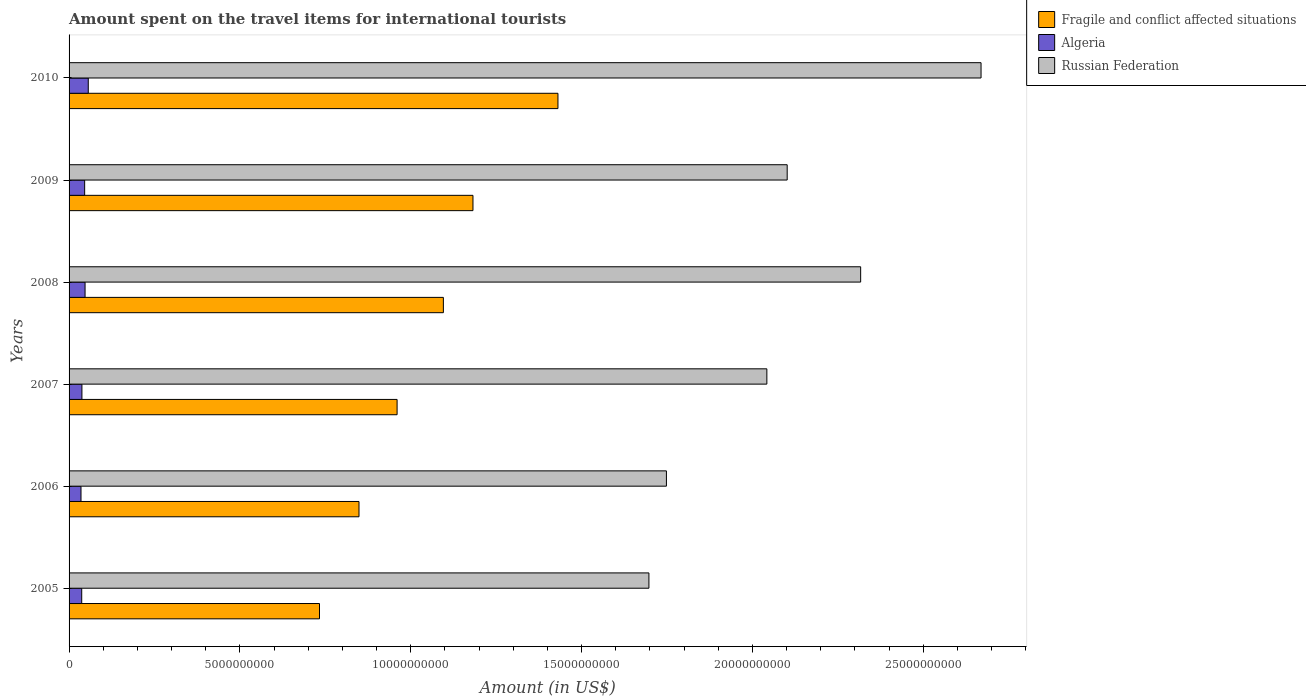Are the number of bars per tick equal to the number of legend labels?
Ensure brevity in your answer.  Yes. What is the amount spent on the travel items for international tourists in Fragile and conflict affected situations in 2009?
Your answer should be very brief. 1.18e+1. Across all years, what is the maximum amount spent on the travel items for international tourists in Algeria?
Give a very brief answer. 5.62e+08. Across all years, what is the minimum amount spent on the travel items for international tourists in Russian Federation?
Your answer should be very brief. 1.70e+1. In which year was the amount spent on the travel items for international tourists in Fragile and conflict affected situations minimum?
Offer a terse response. 2005. What is the total amount spent on the travel items for international tourists in Fragile and conflict affected situations in the graph?
Keep it short and to the point. 6.25e+1. What is the difference between the amount spent on the travel items for international tourists in Russian Federation in 2006 and that in 2008?
Provide a succinct answer. -5.68e+09. What is the difference between the amount spent on the travel items for international tourists in Russian Federation in 2010 and the amount spent on the travel items for international tourists in Algeria in 2008?
Give a very brief answer. 2.62e+1. What is the average amount spent on the travel items for international tourists in Russian Federation per year?
Your answer should be very brief. 2.10e+1. In the year 2009, what is the difference between the amount spent on the travel items for international tourists in Russian Federation and amount spent on the travel items for international tourists in Algeria?
Provide a succinct answer. 2.06e+1. What is the ratio of the amount spent on the travel items for international tourists in Russian Federation in 2009 to that in 2010?
Your answer should be very brief. 0.79. Is the difference between the amount spent on the travel items for international tourists in Russian Federation in 2006 and 2010 greater than the difference between the amount spent on the travel items for international tourists in Algeria in 2006 and 2010?
Give a very brief answer. No. What is the difference between the highest and the second highest amount spent on the travel items for international tourists in Fragile and conflict affected situations?
Offer a very short reply. 2.49e+09. What is the difference between the highest and the lowest amount spent on the travel items for international tourists in Algeria?
Provide a succinct answer. 2.13e+08. Is the sum of the amount spent on the travel items for international tourists in Russian Federation in 2007 and 2008 greater than the maximum amount spent on the travel items for international tourists in Fragile and conflict affected situations across all years?
Your answer should be compact. Yes. What does the 1st bar from the top in 2008 represents?
Offer a very short reply. Russian Federation. What does the 2nd bar from the bottom in 2006 represents?
Your answer should be compact. Algeria. How many bars are there?
Your answer should be compact. 18. How many years are there in the graph?
Keep it short and to the point. 6. Are the values on the major ticks of X-axis written in scientific E-notation?
Offer a very short reply. No. Does the graph contain grids?
Provide a short and direct response. No. Where does the legend appear in the graph?
Provide a succinct answer. Top right. How many legend labels are there?
Make the answer very short. 3. What is the title of the graph?
Make the answer very short. Amount spent on the travel items for international tourists. What is the label or title of the X-axis?
Make the answer very short. Amount (in US$). What is the Amount (in US$) in Fragile and conflict affected situations in 2005?
Your answer should be very brief. 7.33e+09. What is the Amount (in US$) in Algeria in 2005?
Provide a succinct answer. 3.70e+08. What is the Amount (in US$) of Russian Federation in 2005?
Provide a succinct answer. 1.70e+1. What is the Amount (in US$) in Fragile and conflict affected situations in 2006?
Offer a terse response. 8.49e+09. What is the Amount (in US$) of Algeria in 2006?
Provide a short and direct response. 3.49e+08. What is the Amount (in US$) in Russian Federation in 2006?
Offer a terse response. 1.75e+1. What is the Amount (in US$) in Fragile and conflict affected situations in 2007?
Provide a short and direct response. 9.60e+09. What is the Amount (in US$) in Algeria in 2007?
Provide a succinct answer. 3.76e+08. What is the Amount (in US$) in Russian Federation in 2007?
Give a very brief answer. 2.04e+1. What is the Amount (in US$) in Fragile and conflict affected situations in 2008?
Ensure brevity in your answer.  1.10e+1. What is the Amount (in US$) in Algeria in 2008?
Give a very brief answer. 4.68e+08. What is the Amount (in US$) of Russian Federation in 2008?
Provide a succinct answer. 2.32e+1. What is the Amount (in US$) of Fragile and conflict affected situations in 2009?
Provide a succinct answer. 1.18e+1. What is the Amount (in US$) of Algeria in 2009?
Your response must be concise. 4.56e+08. What is the Amount (in US$) of Russian Federation in 2009?
Your answer should be compact. 2.10e+1. What is the Amount (in US$) in Fragile and conflict affected situations in 2010?
Offer a very short reply. 1.43e+1. What is the Amount (in US$) in Algeria in 2010?
Your answer should be compact. 5.62e+08. What is the Amount (in US$) of Russian Federation in 2010?
Provide a short and direct response. 2.67e+1. Across all years, what is the maximum Amount (in US$) of Fragile and conflict affected situations?
Your answer should be very brief. 1.43e+1. Across all years, what is the maximum Amount (in US$) in Algeria?
Provide a short and direct response. 5.62e+08. Across all years, what is the maximum Amount (in US$) of Russian Federation?
Make the answer very short. 2.67e+1. Across all years, what is the minimum Amount (in US$) of Fragile and conflict affected situations?
Ensure brevity in your answer.  7.33e+09. Across all years, what is the minimum Amount (in US$) in Algeria?
Offer a very short reply. 3.49e+08. Across all years, what is the minimum Amount (in US$) in Russian Federation?
Offer a terse response. 1.70e+1. What is the total Amount (in US$) of Fragile and conflict affected situations in the graph?
Offer a very short reply. 6.25e+1. What is the total Amount (in US$) of Algeria in the graph?
Your answer should be very brief. 2.58e+09. What is the total Amount (in US$) in Russian Federation in the graph?
Provide a short and direct response. 1.26e+11. What is the difference between the Amount (in US$) in Fragile and conflict affected situations in 2005 and that in 2006?
Your response must be concise. -1.16e+09. What is the difference between the Amount (in US$) of Algeria in 2005 and that in 2006?
Provide a succinct answer. 2.10e+07. What is the difference between the Amount (in US$) of Russian Federation in 2005 and that in 2006?
Keep it short and to the point. -5.12e+08. What is the difference between the Amount (in US$) in Fragile and conflict affected situations in 2005 and that in 2007?
Your response must be concise. -2.27e+09. What is the difference between the Amount (in US$) of Algeria in 2005 and that in 2007?
Your answer should be very brief. -6.00e+06. What is the difference between the Amount (in US$) in Russian Federation in 2005 and that in 2007?
Make the answer very short. -3.45e+09. What is the difference between the Amount (in US$) in Fragile and conflict affected situations in 2005 and that in 2008?
Your answer should be compact. -3.63e+09. What is the difference between the Amount (in US$) of Algeria in 2005 and that in 2008?
Keep it short and to the point. -9.80e+07. What is the difference between the Amount (in US$) in Russian Federation in 2005 and that in 2008?
Provide a short and direct response. -6.20e+09. What is the difference between the Amount (in US$) of Fragile and conflict affected situations in 2005 and that in 2009?
Offer a very short reply. -4.49e+09. What is the difference between the Amount (in US$) of Algeria in 2005 and that in 2009?
Your response must be concise. -8.60e+07. What is the difference between the Amount (in US$) in Russian Federation in 2005 and that in 2009?
Provide a succinct answer. -4.05e+09. What is the difference between the Amount (in US$) of Fragile and conflict affected situations in 2005 and that in 2010?
Provide a short and direct response. -6.98e+09. What is the difference between the Amount (in US$) of Algeria in 2005 and that in 2010?
Offer a very short reply. -1.92e+08. What is the difference between the Amount (in US$) of Russian Federation in 2005 and that in 2010?
Ensure brevity in your answer.  -9.72e+09. What is the difference between the Amount (in US$) of Fragile and conflict affected situations in 2006 and that in 2007?
Give a very brief answer. -1.11e+09. What is the difference between the Amount (in US$) in Algeria in 2006 and that in 2007?
Your response must be concise. -2.70e+07. What is the difference between the Amount (in US$) of Russian Federation in 2006 and that in 2007?
Provide a succinct answer. -2.94e+09. What is the difference between the Amount (in US$) in Fragile and conflict affected situations in 2006 and that in 2008?
Give a very brief answer. -2.47e+09. What is the difference between the Amount (in US$) in Algeria in 2006 and that in 2008?
Keep it short and to the point. -1.19e+08. What is the difference between the Amount (in US$) in Russian Federation in 2006 and that in 2008?
Provide a short and direct response. -5.68e+09. What is the difference between the Amount (in US$) of Fragile and conflict affected situations in 2006 and that in 2009?
Your response must be concise. -3.34e+09. What is the difference between the Amount (in US$) of Algeria in 2006 and that in 2009?
Keep it short and to the point. -1.07e+08. What is the difference between the Amount (in US$) of Russian Federation in 2006 and that in 2009?
Your response must be concise. -3.54e+09. What is the difference between the Amount (in US$) of Fragile and conflict affected situations in 2006 and that in 2010?
Make the answer very short. -5.82e+09. What is the difference between the Amount (in US$) in Algeria in 2006 and that in 2010?
Give a very brief answer. -2.13e+08. What is the difference between the Amount (in US$) in Russian Federation in 2006 and that in 2010?
Ensure brevity in your answer.  -9.21e+09. What is the difference between the Amount (in US$) in Fragile and conflict affected situations in 2007 and that in 2008?
Give a very brief answer. -1.35e+09. What is the difference between the Amount (in US$) in Algeria in 2007 and that in 2008?
Provide a short and direct response. -9.20e+07. What is the difference between the Amount (in US$) of Russian Federation in 2007 and that in 2008?
Provide a short and direct response. -2.74e+09. What is the difference between the Amount (in US$) of Fragile and conflict affected situations in 2007 and that in 2009?
Ensure brevity in your answer.  -2.22e+09. What is the difference between the Amount (in US$) of Algeria in 2007 and that in 2009?
Offer a terse response. -8.00e+07. What is the difference between the Amount (in US$) of Russian Federation in 2007 and that in 2009?
Give a very brief answer. -5.95e+08. What is the difference between the Amount (in US$) in Fragile and conflict affected situations in 2007 and that in 2010?
Offer a very short reply. -4.71e+09. What is the difference between the Amount (in US$) of Algeria in 2007 and that in 2010?
Keep it short and to the point. -1.86e+08. What is the difference between the Amount (in US$) of Russian Federation in 2007 and that in 2010?
Make the answer very short. -6.27e+09. What is the difference between the Amount (in US$) of Fragile and conflict affected situations in 2008 and that in 2009?
Your answer should be compact. -8.66e+08. What is the difference between the Amount (in US$) of Russian Federation in 2008 and that in 2009?
Your answer should be compact. 2.15e+09. What is the difference between the Amount (in US$) in Fragile and conflict affected situations in 2008 and that in 2010?
Make the answer very short. -3.35e+09. What is the difference between the Amount (in US$) in Algeria in 2008 and that in 2010?
Ensure brevity in your answer.  -9.40e+07. What is the difference between the Amount (in US$) in Russian Federation in 2008 and that in 2010?
Provide a short and direct response. -3.52e+09. What is the difference between the Amount (in US$) in Fragile and conflict affected situations in 2009 and that in 2010?
Your response must be concise. -2.49e+09. What is the difference between the Amount (in US$) of Algeria in 2009 and that in 2010?
Your response must be concise. -1.06e+08. What is the difference between the Amount (in US$) of Russian Federation in 2009 and that in 2010?
Make the answer very short. -5.67e+09. What is the difference between the Amount (in US$) of Fragile and conflict affected situations in 2005 and the Amount (in US$) of Algeria in 2006?
Your answer should be very brief. 6.98e+09. What is the difference between the Amount (in US$) in Fragile and conflict affected situations in 2005 and the Amount (in US$) in Russian Federation in 2006?
Your answer should be compact. -1.02e+1. What is the difference between the Amount (in US$) in Algeria in 2005 and the Amount (in US$) in Russian Federation in 2006?
Offer a terse response. -1.71e+1. What is the difference between the Amount (in US$) of Fragile and conflict affected situations in 2005 and the Amount (in US$) of Algeria in 2007?
Your response must be concise. 6.95e+09. What is the difference between the Amount (in US$) in Fragile and conflict affected situations in 2005 and the Amount (in US$) in Russian Federation in 2007?
Your answer should be compact. -1.31e+1. What is the difference between the Amount (in US$) of Algeria in 2005 and the Amount (in US$) of Russian Federation in 2007?
Keep it short and to the point. -2.01e+1. What is the difference between the Amount (in US$) of Fragile and conflict affected situations in 2005 and the Amount (in US$) of Algeria in 2008?
Your response must be concise. 6.86e+09. What is the difference between the Amount (in US$) of Fragile and conflict affected situations in 2005 and the Amount (in US$) of Russian Federation in 2008?
Your answer should be very brief. -1.58e+1. What is the difference between the Amount (in US$) of Algeria in 2005 and the Amount (in US$) of Russian Federation in 2008?
Provide a short and direct response. -2.28e+1. What is the difference between the Amount (in US$) of Fragile and conflict affected situations in 2005 and the Amount (in US$) of Algeria in 2009?
Your response must be concise. 6.87e+09. What is the difference between the Amount (in US$) of Fragile and conflict affected situations in 2005 and the Amount (in US$) of Russian Federation in 2009?
Provide a succinct answer. -1.37e+1. What is the difference between the Amount (in US$) in Algeria in 2005 and the Amount (in US$) in Russian Federation in 2009?
Provide a succinct answer. -2.06e+1. What is the difference between the Amount (in US$) of Fragile and conflict affected situations in 2005 and the Amount (in US$) of Algeria in 2010?
Provide a succinct answer. 6.77e+09. What is the difference between the Amount (in US$) of Fragile and conflict affected situations in 2005 and the Amount (in US$) of Russian Federation in 2010?
Provide a short and direct response. -1.94e+1. What is the difference between the Amount (in US$) of Algeria in 2005 and the Amount (in US$) of Russian Federation in 2010?
Keep it short and to the point. -2.63e+1. What is the difference between the Amount (in US$) in Fragile and conflict affected situations in 2006 and the Amount (in US$) in Algeria in 2007?
Your response must be concise. 8.11e+09. What is the difference between the Amount (in US$) in Fragile and conflict affected situations in 2006 and the Amount (in US$) in Russian Federation in 2007?
Your answer should be compact. -1.19e+1. What is the difference between the Amount (in US$) of Algeria in 2006 and the Amount (in US$) of Russian Federation in 2007?
Ensure brevity in your answer.  -2.01e+1. What is the difference between the Amount (in US$) of Fragile and conflict affected situations in 2006 and the Amount (in US$) of Algeria in 2008?
Your answer should be compact. 8.02e+09. What is the difference between the Amount (in US$) of Fragile and conflict affected situations in 2006 and the Amount (in US$) of Russian Federation in 2008?
Provide a succinct answer. -1.47e+1. What is the difference between the Amount (in US$) of Algeria in 2006 and the Amount (in US$) of Russian Federation in 2008?
Make the answer very short. -2.28e+1. What is the difference between the Amount (in US$) of Fragile and conflict affected situations in 2006 and the Amount (in US$) of Algeria in 2009?
Make the answer very short. 8.03e+09. What is the difference between the Amount (in US$) in Fragile and conflict affected situations in 2006 and the Amount (in US$) in Russian Federation in 2009?
Give a very brief answer. -1.25e+1. What is the difference between the Amount (in US$) in Algeria in 2006 and the Amount (in US$) in Russian Federation in 2009?
Offer a very short reply. -2.07e+1. What is the difference between the Amount (in US$) in Fragile and conflict affected situations in 2006 and the Amount (in US$) in Algeria in 2010?
Give a very brief answer. 7.92e+09. What is the difference between the Amount (in US$) in Fragile and conflict affected situations in 2006 and the Amount (in US$) in Russian Federation in 2010?
Your answer should be compact. -1.82e+1. What is the difference between the Amount (in US$) in Algeria in 2006 and the Amount (in US$) in Russian Federation in 2010?
Make the answer very short. -2.63e+1. What is the difference between the Amount (in US$) of Fragile and conflict affected situations in 2007 and the Amount (in US$) of Algeria in 2008?
Provide a succinct answer. 9.13e+09. What is the difference between the Amount (in US$) in Fragile and conflict affected situations in 2007 and the Amount (in US$) in Russian Federation in 2008?
Your answer should be compact. -1.36e+1. What is the difference between the Amount (in US$) of Algeria in 2007 and the Amount (in US$) of Russian Federation in 2008?
Offer a very short reply. -2.28e+1. What is the difference between the Amount (in US$) of Fragile and conflict affected situations in 2007 and the Amount (in US$) of Algeria in 2009?
Offer a very short reply. 9.14e+09. What is the difference between the Amount (in US$) in Fragile and conflict affected situations in 2007 and the Amount (in US$) in Russian Federation in 2009?
Your answer should be compact. -1.14e+1. What is the difference between the Amount (in US$) in Algeria in 2007 and the Amount (in US$) in Russian Federation in 2009?
Offer a terse response. -2.06e+1. What is the difference between the Amount (in US$) in Fragile and conflict affected situations in 2007 and the Amount (in US$) in Algeria in 2010?
Your answer should be very brief. 9.04e+09. What is the difference between the Amount (in US$) of Fragile and conflict affected situations in 2007 and the Amount (in US$) of Russian Federation in 2010?
Your response must be concise. -1.71e+1. What is the difference between the Amount (in US$) in Algeria in 2007 and the Amount (in US$) in Russian Federation in 2010?
Provide a short and direct response. -2.63e+1. What is the difference between the Amount (in US$) of Fragile and conflict affected situations in 2008 and the Amount (in US$) of Algeria in 2009?
Ensure brevity in your answer.  1.05e+1. What is the difference between the Amount (in US$) in Fragile and conflict affected situations in 2008 and the Amount (in US$) in Russian Federation in 2009?
Offer a terse response. -1.01e+1. What is the difference between the Amount (in US$) in Algeria in 2008 and the Amount (in US$) in Russian Federation in 2009?
Your response must be concise. -2.06e+1. What is the difference between the Amount (in US$) of Fragile and conflict affected situations in 2008 and the Amount (in US$) of Algeria in 2010?
Your answer should be compact. 1.04e+1. What is the difference between the Amount (in US$) in Fragile and conflict affected situations in 2008 and the Amount (in US$) in Russian Federation in 2010?
Ensure brevity in your answer.  -1.57e+1. What is the difference between the Amount (in US$) of Algeria in 2008 and the Amount (in US$) of Russian Federation in 2010?
Your answer should be compact. -2.62e+1. What is the difference between the Amount (in US$) in Fragile and conflict affected situations in 2009 and the Amount (in US$) in Algeria in 2010?
Provide a succinct answer. 1.13e+1. What is the difference between the Amount (in US$) in Fragile and conflict affected situations in 2009 and the Amount (in US$) in Russian Federation in 2010?
Offer a very short reply. -1.49e+1. What is the difference between the Amount (in US$) of Algeria in 2009 and the Amount (in US$) of Russian Federation in 2010?
Make the answer very short. -2.62e+1. What is the average Amount (in US$) in Fragile and conflict affected situations per year?
Keep it short and to the point. 1.04e+1. What is the average Amount (in US$) in Algeria per year?
Your answer should be compact. 4.30e+08. What is the average Amount (in US$) of Russian Federation per year?
Keep it short and to the point. 2.10e+1. In the year 2005, what is the difference between the Amount (in US$) in Fragile and conflict affected situations and Amount (in US$) in Algeria?
Your answer should be very brief. 6.96e+09. In the year 2005, what is the difference between the Amount (in US$) of Fragile and conflict affected situations and Amount (in US$) of Russian Federation?
Your answer should be compact. -9.64e+09. In the year 2005, what is the difference between the Amount (in US$) in Algeria and Amount (in US$) in Russian Federation?
Your response must be concise. -1.66e+1. In the year 2006, what is the difference between the Amount (in US$) in Fragile and conflict affected situations and Amount (in US$) in Algeria?
Your answer should be compact. 8.14e+09. In the year 2006, what is the difference between the Amount (in US$) of Fragile and conflict affected situations and Amount (in US$) of Russian Federation?
Make the answer very short. -9.00e+09. In the year 2006, what is the difference between the Amount (in US$) of Algeria and Amount (in US$) of Russian Federation?
Provide a short and direct response. -1.71e+1. In the year 2007, what is the difference between the Amount (in US$) of Fragile and conflict affected situations and Amount (in US$) of Algeria?
Offer a terse response. 9.22e+09. In the year 2007, what is the difference between the Amount (in US$) of Fragile and conflict affected situations and Amount (in US$) of Russian Federation?
Your response must be concise. -1.08e+1. In the year 2007, what is the difference between the Amount (in US$) of Algeria and Amount (in US$) of Russian Federation?
Keep it short and to the point. -2.00e+1. In the year 2008, what is the difference between the Amount (in US$) of Fragile and conflict affected situations and Amount (in US$) of Algeria?
Your answer should be very brief. 1.05e+1. In the year 2008, what is the difference between the Amount (in US$) of Fragile and conflict affected situations and Amount (in US$) of Russian Federation?
Offer a very short reply. -1.22e+1. In the year 2008, what is the difference between the Amount (in US$) in Algeria and Amount (in US$) in Russian Federation?
Offer a very short reply. -2.27e+1. In the year 2009, what is the difference between the Amount (in US$) in Fragile and conflict affected situations and Amount (in US$) in Algeria?
Offer a very short reply. 1.14e+1. In the year 2009, what is the difference between the Amount (in US$) in Fragile and conflict affected situations and Amount (in US$) in Russian Federation?
Offer a very short reply. -9.20e+09. In the year 2009, what is the difference between the Amount (in US$) of Algeria and Amount (in US$) of Russian Federation?
Provide a short and direct response. -2.06e+1. In the year 2010, what is the difference between the Amount (in US$) of Fragile and conflict affected situations and Amount (in US$) of Algeria?
Give a very brief answer. 1.37e+1. In the year 2010, what is the difference between the Amount (in US$) in Fragile and conflict affected situations and Amount (in US$) in Russian Federation?
Provide a succinct answer. -1.24e+1. In the year 2010, what is the difference between the Amount (in US$) of Algeria and Amount (in US$) of Russian Federation?
Your response must be concise. -2.61e+1. What is the ratio of the Amount (in US$) of Fragile and conflict affected situations in 2005 to that in 2006?
Ensure brevity in your answer.  0.86. What is the ratio of the Amount (in US$) of Algeria in 2005 to that in 2006?
Ensure brevity in your answer.  1.06. What is the ratio of the Amount (in US$) in Russian Federation in 2005 to that in 2006?
Provide a succinct answer. 0.97. What is the ratio of the Amount (in US$) in Fragile and conflict affected situations in 2005 to that in 2007?
Offer a terse response. 0.76. What is the ratio of the Amount (in US$) of Algeria in 2005 to that in 2007?
Keep it short and to the point. 0.98. What is the ratio of the Amount (in US$) in Russian Federation in 2005 to that in 2007?
Offer a very short reply. 0.83. What is the ratio of the Amount (in US$) of Fragile and conflict affected situations in 2005 to that in 2008?
Offer a very short reply. 0.67. What is the ratio of the Amount (in US$) of Algeria in 2005 to that in 2008?
Make the answer very short. 0.79. What is the ratio of the Amount (in US$) of Russian Federation in 2005 to that in 2008?
Provide a succinct answer. 0.73. What is the ratio of the Amount (in US$) in Fragile and conflict affected situations in 2005 to that in 2009?
Provide a succinct answer. 0.62. What is the ratio of the Amount (in US$) in Algeria in 2005 to that in 2009?
Your response must be concise. 0.81. What is the ratio of the Amount (in US$) of Russian Federation in 2005 to that in 2009?
Make the answer very short. 0.81. What is the ratio of the Amount (in US$) of Fragile and conflict affected situations in 2005 to that in 2010?
Keep it short and to the point. 0.51. What is the ratio of the Amount (in US$) of Algeria in 2005 to that in 2010?
Offer a very short reply. 0.66. What is the ratio of the Amount (in US$) in Russian Federation in 2005 to that in 2010?
Provide a succinct answer. 0.64. What is the ratio of the Amount (in US$) in Fragile and conflict affected situations in 2006 to that in 2007?
Make the answer very short. 0.88. What is the ratio of the Amount (in US$) in Algeria in 2006 to that in 2007?
Offer a very short reply. 0.93. What is the ratio of the Amount (in US$) in Russian Federation in 2006 to that in 2007?
Give a very brief answer. 0.86. What is the ratio of the Amount (in US$) in Fragile and conflict affected situations in 2006 to that in 2008?
Provide a short and direct response. 0.77. What is the ratio of the Amount (in US$) in Algeria in 2006 to that in 2008?
Provide a short and direct response. 0.75. What is the ratio of the Amount (in US$) in Russian Federation in 2006 to that in 2008?
Provide a short and direct response. 0.75. What is the ratio of the Amount (in US$) of Fragile and conflict affected situations in 2006 to that in 2009?
Give a very brief answer. 0.72. What is the ratio of the Amount (in US$) of Algeria in 2006 to that in 2009?
Your answer should be compact. 0.77. What is the ratio of the Amount (in US$) in Russian Federation in 2006 to that in 2009?
Provide a succinct answer. 0.83. What is the ratio of the Amount (in US$) of Fragile and conflict affected situations in 2006 to that in 2010?
Your answer should be compact. 0.59. What is the ratio of the Amount (in US$) of Algeria in 2006 to that in 2010?
Keep it short and to the point. 0.62. What is the ratio of the Amount (in US$) in Russian Federation in 2006 to that in 2010?
Give a very brief answer. 0.66. What is the ratio of the Amount (in US$) in Fragile and conflict affected situations in 2007 to that in 2008?
Offer a terse response. 0.88. What is the ratio of the Amount (in US$) in Algeria in 2007 to that in 2008?
Your answer should be very brief. 0.8. What is the ratio of the Amount (in US$) in Russian Federation in 2007 to that in 2008?
Your answer should be compact. 0.88. What is the ratio of the Amount (in US$) in Fragile and conflict affected situations in 2007 to that in 2009?
Ensure brevity in your answer.  0.81. What is the ratio of the Amount (in US$) in Algeria in 2007 to that in 2009?
Your response must be concise. 0.82. What is the ratio of the Amount (in US$) in Russian Federation in 2007 to that in 2009?
Make the answer very short. 0.97. What is the ratio of the Amount (in US$) of Fragile and conflict affected situations in 2007 to that in 2010?
Provide a short and direct response. 0.67. What is the ratio of the Amount (in US$) in Algeria in 2007 to that in 2010?
Make the answer very short. 0.67. What is the ratio of the Amount (in US$) of Russian Federation in 2007 to that in 2010?
Offer a very short reply. 0.77. What is the ratio of the Amount (in US$) of Fragile and conflict affected situations in 2008 to that in 2009?
Keep it short and to the point. 0.93. What is the ratio of the Amount (in US$) in Algeria in 2008 to that in 2009?
Provide a succinct answer. 1.03. What is the ratio of the Amount (in US$) of Russian Federation in 2008 to that in 2009?
Your answer should be very brief. 1.1. What is the ratio of the Amount (in US$) of Fragile and conflict affected situations in 2008 to that in 2010?
Give a very brief answer. 0.77. What is the ratio of the Amount (in US$) in Algeria in 2008 to that in 2010?
Your answer should be very brief. 0.83. What is the ratio of the Amount (in US$) in Russian Federation in 2008 to that in 2010?
Offer a very short reply. 0.87. What is the ratio of the Amount (in US$) in Fragile and conflict affected situations in 2009 to that in 2010?
Provide a short and direct response. 0.83. What is the ratio of the Amount (in US$) of Algeria in 2009 to that in 2010?
Provide a short and direct response. 0.81. What is the ratio of the Amount (in US$) of Russian Federation in 2009 to that in 2010?
Ensure brevity in your answer.  0.79. What is the difference between the highest and the second highest Amount (in US$) of Fragile and conflict affected situations?
Provide a succinct answer. 2.49e+09. What is the difference between the highest and the second highest Amount (in US$) in Algeria?
Offer a very short reply. 9.40e+07. What is the difference between the highest and the second highest Amount (in US$) of Russian Federation?
Ensure brevity in your answer.  3.52e+09. What is the difference between the highest and the lowest Amount (in US$) in Fragile and conflict affected situations?
Provide a short and direct response. 6.98e+09. What is the difference between the highest and the lowest Amount (in US$) of Algeria?
Make the answer very short. 2.13e+08. What is the difference between the highest and the lowest Amount (in US$) of Russian Federation?
Keep it short and to the point. 9.72e+09. 